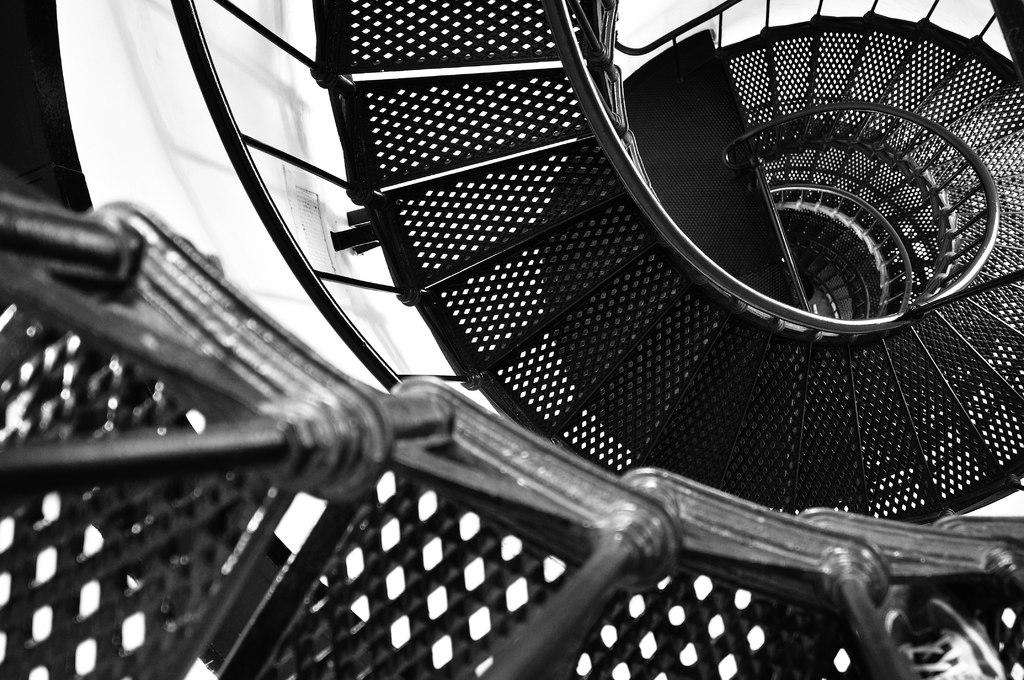What type of objects are in the foreground of the image? There are metal objects in the foreground of the image. What architectural feature is located in the center of the image? There is a staircase in the center of the image. What else can be seen in the center of the image besides the staircase? There are some objects in the center of the image. What type of railway is visible in the image? There is no railway present in the image. Are there any plants or plantation visible in the image? There is no plant or plantation present in the image. 